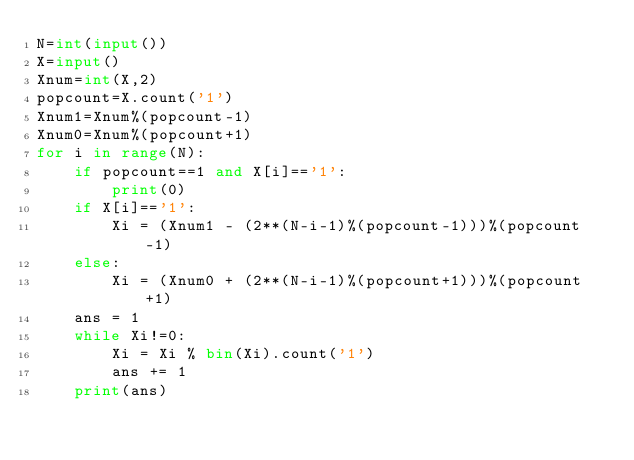Convert code to text. <code><loc_0><loc_0><loc_500><loc_500><_Python_>N=int(input())
X=input()
Xnum=int(X,2)
popcount=X.count('1')
Xnum1=Xnum%(popcount-1)
Xnum0=Xnum%(popcount+1)
for i in range(N):
    if popcount==1 and X[i]=='1':
        print(0)
    if X[i]=='1':
        Xi = (Xnum1 - (2**(N-i-1)%(popcount-1)))%(popcount-1)
    else:
        Xi = (Xnum0 + (2**(N-i-1)%(popcount+1)))%(popcount+1)
    ans = 1
    while Xi!=0:
        Xi = Xi % bin(Xi).count('1')
        ans += 1
    print(ans)</code> 